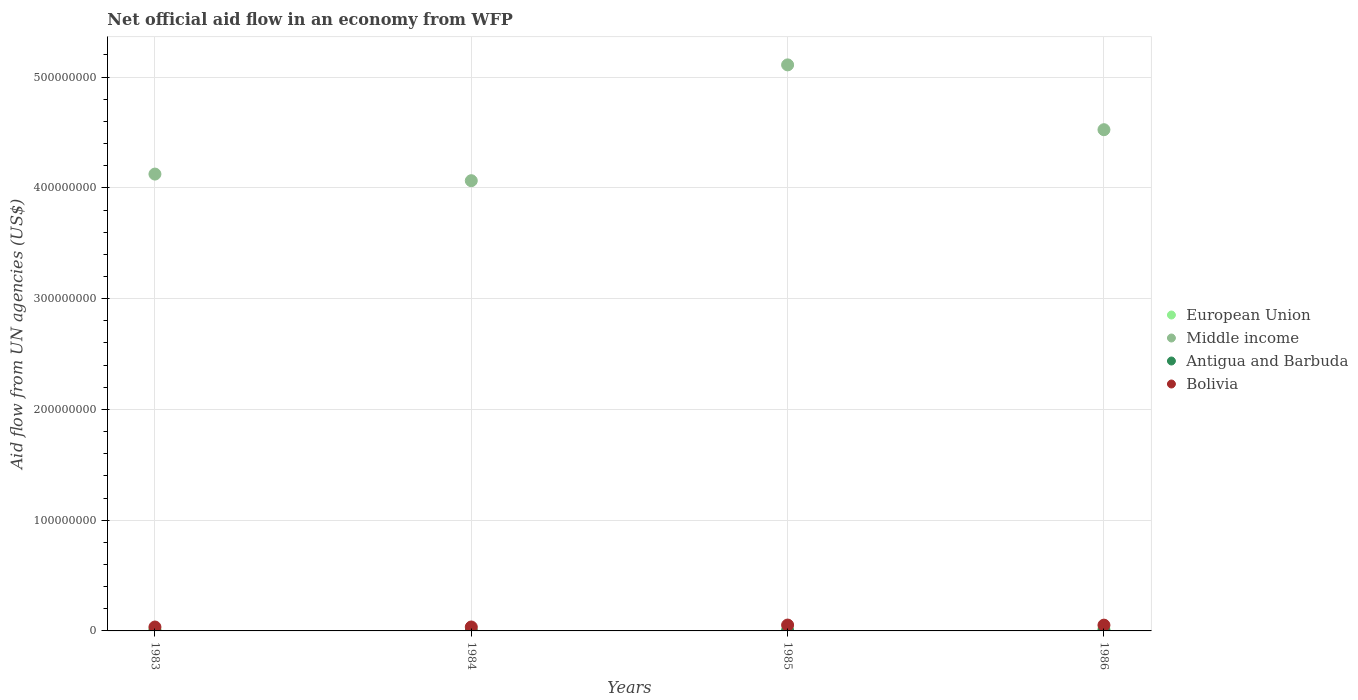How many different coloured dotlines are there?
Your response must be concise. 4. What is the net official aid flow in European Union in 1986?
Provide a short and direct response. 1.63e+06. Across all years, what is the maximum net official aid flow in Middle income?
Make the answer very short. 5.11e+08. Across all years, what is the minimum net official aid flow in Bolivia?
Your answer should be very brief. 3.52e+06. What is the total net official aid flow in Antigua and Barbuda in the graph?
Make the answer very short. 3.80e+05. What is the difference between the net official aid flow in Antigua and Barbuda in 1983 and that in 1984?
Give a very brief answer. 8.00e+04. What is the difference between the net official aid flow in Antigua and Barbuda in 1985 and the net official aid flow in Bolivia in 1983?
Provide a succinct answer. -3.39e+06. What is the average net official aid flow in Middle income per year?
Your answer should be very brief. 4.46e+08. In the year 1986, what is the difference between the net official aid flow in European Union and net official aid flow in Antigua and Barbuda?
Your answer should be very brief. 1.54e+06. In how many years, is the net official aid flow in European Union greater than 180000000 US$?
Make the answer very short. 0. What is the ratio of the net official aid flow in European Union in 1985 to that in 1986?
Offer a terse response. 0.45. What is the difference between the highest and the second highest net official aid flow in Middle income?
Your response must be concise. 5.85e+07. What is the difference between the highest and the lowest net official aid flow in Bolivia?
Give a very brief answer. 1.78e+06. In how many years, is the net official aid flow in Bolivia greater than the average net official aid flow in Bolivia taken over all years?
Your response must be concise. 2. Is the sum of the net official aid flow in Antigua and Barbuda in 1985 and 1986 greater than the maximum net official aid flow in European Union across all years?
Provide a short and direct response. No. Is it the case that in every year, the sum of the net official aid flow in Antigua and Barbuda and net official aid flow in Middle income  is greater than the sum of net official aid flow in Bolivia and net official aid flow in European Union?
Provide a short and direct response. Yes. Does the net official aid flow in European Union monotonically increase over the years?
Offer a very short reply. No. Is the net official aid flow in Middle income strictly greater than the net official aid flow in Bolivia over the years?
Offer a very short reply. Yes. How many dotlines are there?
Provide a succinct answer. 4. Are the values on the major ticks of Y-axis written in scientific E-notation?
Give a very brief answer. No. How many legend labels are there?
Offer a very short reply. 4. What is the title of the graph?
Provide a short and direct response. Net official aid flow in an economy from WFP. What is the label or title of the Y-axis?
Make the answer very short. Aid flow from UN agencies (US$). What is the Aid flow from UN agencies (US$) in European Union in 1983?
Keep it short and to the point. 1.25e+06. What is the Aid flow from UN agencies (US$) of Middle income in 1983?
Your answer should be compact. 4.12e+08. What is the Aid flow from UN agencies (US$) of Antigua and Barbuda in 1983?
Offer a very short reply. 1.20e+05. What is the Aid flow from UN agencies (US$) of Bolivia in 1983?
Your answer should be compact. 3.52e+06. What is the Aid flow from UN agencies (US$) in European Union in 1984?
Give a very brief answer. 2.20e+05. What is the Aid flow from UN agencies (US$) of Middle income in 1984?
Offer a very short reply. 4.06e+08. What is the Aid flow from UN agencies (US$) of Bolivia in 1984?
Offer a very short reply. 3.55e+06. What is the Aid flow from UN agencies (US$) in European Union in 1985?
Ensure brevity in your answer.  7.40e+05. What is the Aid flow from UN agencies (US$) of Middle income in 1985?
Your answer should be compact. 5.11e+08. What is the Aid flow from UN agencies (US$) in Bolivia in 1985?
Offer a very short reply. 5.30e+06. What is the Aid flow from UN agencies (US$) of European Union in 1986?
Your response must be concise. 1.63e+06. What is the Aid flow from UN agencies (US$) in Middle income in 1986?
Ensure brevity in your answer.  4.53e+08. What is the Aid flow from UN agencies (US$) of Bolivia in 1986?
Your response must be concise. 5.22e+06. Across all years, what is the maximum Aid flow from UN agencies (US$) in European Union?
Your response must be concise. 1.63e+06. Across all years, what is the maximum Aid flow from UN agencies (US$) of Middle income?
Your answer should be compact. 5.11e+08. Across all years, what is the maximum Aid flow from UN agencies (US$) in Antigua and Barbuda?
Your answer should be very brief. 1.30e+05. Across all years, what is the maximum Aid flow from UN agencies (US$) in Bolivia?
Make the answer very short. 5.30e+06. Across all years, what is the minimum Aid flow from UN agencies (US$) of Middle income?
Ensure brevity in your answer.  4.06e+08. Across all years, what is the minimum Aid flow from UN agencies (US$) of Antigua and Barbuda?
Offer a terse response. 4.00e+04. Across all years, what is the minimum Aid flow from UN agencies (US$) of Bolivia?
Your response must be concise. 3.52e+06. What is the total Aid flow from UN agencies (US$) in European Union in the graph?
Give a very brief answer. 3.84e+06. What is the total Aid flow from UN agencies (US$) of Middle income in the graph?
Provide a short and direct response. 1.78e+09. What is the total Aid flow from UN agencies (US$) in Antigua and Barbuda in the graph?
Offer a very short reply. 3.80e+05. What is the total Aid flow from UN agencies (US$) of Bolivia in the graph?
Your answer should be very brief. 1.76e+07. What is the difference between the Aid flow from UN agencies (US$) of European Union in 1983 and that in 1984?
Offer a very short reply. 1.03e+06. What is the difference between the Aid flow from UN agencies (US$) of Middle income in 1983 and that in 1984?
Your response must be concise. 5.98e+06. What is the difference between the Aid flow from UN agencies (US$) in European Union in 1983 and that in 1985?
Ensure brevity in your answer.  5.10e+05. What is the difference between the Aid flow from UN agencies (US$) in Middle income in 1983 and that in 1985?
Provide a succinct answer. -9.86e+07. What is the difference between the Aid flow from UN agencies (US$) in Antigua and Barbuda in 1983 and that in 1985?
Give a very brief answer. -10000. What is the difference between the Aid flow from UN agencies (US$) in Bolivia in 1983 and that in 1985?
Give a very brief answer. -1.78e+06. What is the difference between the Aid flow from UN agencies (US$) of European Union in 1983 and that in 1986?
Your answer should be compact. -3.80e+05. What is the difference between the Aid flow from UN agencies (US$) in Middle income in 1983 and that in 1986?
Your response must be concise. -4.01e+07. What is the difference between the Aid flow from UN agencies (US$) of Bolivia in 1983 and that in 1986?
Offer a very short reply. -1.70e+06. What is the difference between the Aid flow from UN agencies (US$) in European Union in 1984 and that in 1985?
Give a very brief answer. -5.20e+05. What is the difference between the Aid flow from UN agencies (US$) in Middle income in 1984 and that in 1985?
Your answer should be compact. -1.05e+08. What is the difference between the Aid flow from UN agencies (US$) of Bolivia in 1984 and that in 1985?
Your answer should be compact. -1.75e+06. What is the difference between the Aid flow from UN agencies (US$) in European Union in 1984 and that in 1986?
Give a very brief answer. -1.41e+06. What is the difference between the Aid flow from UN agencies (US$) of Middle income in 1984 and that in 1986?
Give a very brief answer. -4.60e+07. What is the difference between the Aid flow from UN agencies (US$) of Antigua and Barbuda in 1984 and that in 1986?
Provide a short and direct response. -5.00e+04. What is the difference between the Aid flow from UN agencies (US$) in Bolivia in 1984 and that in 1986?
Give a very brief answer. -1.67e+06. What is the difference between the Aid flow from UN agencies (US$) in European Union in 1985 and that in 1986?
Your answer should be compact. -8.90e+05. What is the difference between the Aid flow from UN agencies (US$) of Middle income in 1985 and that in 1986?
Your response must be concise. 5.85e+07. What is the difference between the Aid flow from UN agencies (US$) in Bolivia in 1985 and that in 1986?
Keep it short and to the point. 8.00e+04. What is the difference between the Aid flow from UN agencies (US$) of European Union in 1983 and the Aid flow from UN agencies (US$) of Middle income in 1984?
Your response must be concise. -4.05e+08. What is the difference between the Aid flow from UN agencies (US$) of European Union in 1983 and the Aid flow from UN agencies (US$) of Antigua and Barbuda in 1984?
Your answer should be compact. 1.21e+06. What is the difference between the Aid flow from UN agencies (US$) of European Union in 1983 and the Aid flow from UN agencies (US$) of Bolivia in 1984?
Keep it short and to the point. -2.30e+06. What is the difference between the Aid flow from UN agencies (US$) of Middle income in 1983 and the Aid flow from UN agencies (US$) of Antigua and Barbuda in 1984?
Your answer should be compact. 4.12e+08. What is the difference between the Aid flow from UN agencies (US$) of Middle income in 1983 and the Aid flow from UN agencies (US$) of Bolivia in 1984?
Offer a very short reply. 4.09e+08. What is the difference between the Aid flow from UN agencies (US$) in Antigua and Barbuda in 1983 and the Aid flow from UN agencies (US$) in Bolivia in 1984?
Make the answer very short. -3.43e+06. What is the difference between the Aid flow from UN agencies (US$) of European Union in 1983 and the Aid flow from UN agencies (US$) of Middle income in 1985?
Make the answer very short. -5.10e+08. What is the difference between the Aid flow from UN agencies (US$) of European Union in 1983 and the Aid flow from UN agencies (US$) of Antigua and Barbuda in 1985?
Provide a short and direct response. 1.12e+06. What is the difference between the Aid flow from UN agencies (US$) of European Union in 1983 and the Aid flow from UN agencies (US$) of Bolivia in 1985?
Your answer should be compact. -4.05e+06. What is the difference between the Aid flow from UN agencies (US$) of Middle income in 1983 and the Aid flow from UN agencies (US$) of Antigua and Barbuda in 1985?
Your answer should be compact. 4.12e+08. What is the difference between the Aid flow from UN agencies (US$) of Middle income in 1983 and the Aid flow from UN agencies (US$) of Bolivia in 1985?
Offer a terse response. 4.07e+08. What is the difference between the Aid flow from UN agencies (US$) of Antigua and Barbuda in 1983 and the Aid flow from UN agencies (US$) of Bolivia in 1985?
Provide a short and direct response. -5.18e+06. What is the difference between the Aid flow from UN agencies (US$) of European Union in 1983 and the Aid flow from UN agencies (US$) of Middle income in 1986?
Your answer should be very brief. -4.51e+08. What is the difference between the Aid flow from UN agencies (US$) in European Union in 1983 and the Aid flow from UN agencies (US$) in Antigua and Barbuda in 1986?
Your response must be concise. 1.16e+06. What is the difference between the Aid flow from UN agencies (US$) in European Union in 1983 and the Aid flow from UN agencies (US$) in Bolivia in 1986?
Your answer should be compact. -3.97e+06. What is the difference between the Aid flow from UN agencies (US$) in Middle income in 1983 and the Aid flow from UN agencies (US$) in Antigua and Barbuda in 1986?
Your answer should be very brief. 4.12e+08. What is the difference between the Aid flow from UN agencies (US$) of Middle income in 1983 and the Aid flow from UN agencies (US$) of Bolivia in 1986?
Your answer should be very brief. 4.07e+08. What is the difference between the Aid flow from UN agencies (US$) of Antigua and Barbuda in 1983 and the Aid flow from UN agencies (US$) of Bolivia in 1986?
Provide a succinct answer. -5.10e+06. What is the difference between the Aid flow from UN agencies (US$) in European Union in 1984 and the Aid flow from UN agencies (US$) in Middle income in 1985?
Give a very brief answer. -5.11e+08. What is the difference between the Aid flow from UN agencies (US$) in European Union in 1984 and the Aid flow from UN agencies (US$) in Antigua and Barbuda in 1985?
Keep it short and to the point. 9.00e+04. What is the difference between the Aid flow from UN agencies (US$) of European Union in 1984 and the Aid flow from UN agencies (US$) of Bolivia in 1985?
Make the answer very short. -5.08e+06. What is the difference between the Aid flow from UN agencies (US$) in Middle income in 1984 and the Aid flow from UN agencies (US$) in Antigua and Barbuda in 1985?
Your response must be concise. 4.06e+08. What is the difference between the Aid flow from UN agencies (US$) in Middle income in 1984 and the Aid flow from UN agencies (US$) in Bolivia in 1985?
Your answer should be compact. 4.01e+08. What is the difference between the Aid flow from UN agencies (US$) in Antigua and Barbuda in 1984 and the Aid flow from UN agencies (US$) in Bolivia in 1985?
Offer a very short reply. -5.26e+06. What is the difference between the Aid flow from UN agencies (US$) in European Union in 1984 and the Aid flow from UN agencies (US$) in Middle income in 1986?
Your answer should be compact. -4.52e+08. What is the difference between the Aid flow from UN agencies (US$) of European Union in 1984 and the Aid flow from UN agencies (US$) of Bolivia in 1986?
Provide a succinct answer. -5.00e+06. What is the difference between the Aid flow from UN agencies (US$) in Middle income in 1984 and the Aid flow from UN agencies (US$) in Antigua and Barbuda in 1986?
Ensure brevity in your answer.  4.06e+08. What is the difference between the Aid flow from UN agencies (US$) of Middle income in 1984 and the Aid flow from UN agencies (US$) of Bolivia in 1986?
Offer a very short reply. 4.01e+08. What is the difference between the Aid flow from UN agencies (US$) of Antigua and Barbuda in 1984 and the Aid flow from UN agencies (US$) of Bolivia in 1986?
Your response must be concise. -5.18e+06. What is the difference between the Aid flow from UN agencies (US$) of European Union in 1985 and the Aid flow from UN agencies (US$) of Middle income in 1986?
Your response must be concise. -4.52e+08. What is the difference between the Aid flow from UN agencies (US$) of European Union in 1985 and the Aid flow from UN agencies (US$) of Antigua and Barbuda in 1986?
Ensure brevity in your answer.  6.50e+05. What is the difference between the Aid flow from UN agencies (US$) in European Union in 1985 and the Aid flow from UN agencies (US$) in Bolivia in 1986?
Your answer should be compact. -4.48e+06. What is the difference between the Aid flow from UN agencies (US$) in Middle income in 1985 and the Aid flow from UN agencies (US$) in Antigua and Barbuda in 1986?
Make the answer very short. 5.11e+08. What is the difference between the Aid flow from UN agencies (US$) of Middle income in 1985 and the Aid flow from UN agencies (US$) of Bolivia in 1986?
Offer a terse response. 5.06e+08. What is the difference between the Aid flow from UN agencies (US$) in Antigua and Barbuda in 1985 and the Aid flow from UN agencies (US$) in Bolivia in 1986?
Offer a very short reply. -5.09e+06. What is the average Aid flow from UN agencies (US$) of European Union per year?
Offer a terse response. 9.60e+05. What is the average Aid flow from UN agencies (US$) in Middle income per year?
Make the answer very short. 4.46e+08. What is the average Aid flow from UN agencies (US$) of Antigua and Barbuda per year?
Your answer should be very brief. 9.50e+04. What is the average Aid flow from UN agencies (US$) in Bolivia per year?
Offer a terse response. 4.40e+06. In the year 1983, what is the difference between the Aid flow from UN agencies (US$) in European Union and Aid flow from UN agencies (US$) in Middle income?
Ensure brevity in your answer.  -4.11e+08. In the year 1983, what is the difference between the Aid flow from UN agencies (US$) of European Union and Aid flow from UN agencies (US$) of Antigua and Barbuda?
Offer a very short reply. 1.13e+06. In the year 1983, what is the difference between the Aid flow from UN agencies (US$) in European Union and Aid flow from UN agencies (US$) in Bolivia?
Keep it short and to the point. -2.27e+06. In the year 1983, what is the difference between the Aid flow from UN agencies (US$) of Middle income and Aid flow from UN agencies (US$) of Antigua and Barbuda?
Your answer should be compact. 4.12e+08. In the year 1983, what is the difference between the Aid flow from UN agencies (US$) in Middle income and Aid flow from UN agencies (US$) in Bolivia?
Offer a very short reply. 4.09e+08. In the year 1983, what is the difference between the Aid flow from UN agencies (US$) of Antigua and Barbuda and Aid flow from UN agencies (US$) of Bolivia?
Ensure brevity in your answer.  -3.40e+06. In the year 1984, what is the difference between the Aid flow from UN agencies (US$) of European Union and Aid flow from UN agencies (US$) of Middle income?
Make the answer very short. -4.06e+08. In the year 1984, what is the difference between the Aid flow from UN agencies (US$) of European Union and Aid flow from UN agencies (US$) of Bolivia?
Your answer should be very brief. -3.33e+06. In the year 1984, what is the difference between the Aid flow from UN agencies (US$) in Middle income and Aid flow from UN agencies (US$) in Antigua and Barbuda?
Provide a succinct answer. 4.06e+08. In the year 1984, what is the difference between the Aid flow from UN agencies (US$) in Middle income and Aid flow from UN agencies (US$) in Bolivia?
Ensure brevity in your answer.  4.03e+08. In the year 1984, what is the difference between the Aid flow from UN agencies (US$) in Antigua and Barbuda and Aid flow from UN agencies (US$) in Bolivia?
Your response must be concise. -3.51e+06. In the year 1985, what is the difference between the Aid flow from UN agencies (US$) in European Union and Aid flow from UN agencies (US$) in Middle income?
Offer a terse response. -5.10e+08. In the year 1985, what is the difference between the Aid flow from UN agencies (US$) in European Union and Aid flow from UN agencies (US$) in Bolivia?
Ensure brevity in your answer.  -4.56e+06. In the year 1985, what is the difference between the Aid flow from UN agencies (US$) of Middle income and Aid flow from UN agencies (US$) of Antigua and Barbuda?
Make the answer very short. 5.11e+08. In the year 1985, what is the difference between the Aid flow from UN agencies (US$) in Middle income and Aid flow from UN agencies (US$) in Bolivia?
Provide a short and direct response. 5.06e+08. In the year 1985, what is the difference between the Aid flow from UN agencies (US$) in Antigua and Barbuda and Aid flow from UN agencies (US$) in Bolivia?
Your response must be concise. -5.17e+06. In the year 1986, what is the difference between the Aid flow from UN agencies (US$) in European Union and Aid flow from UN agencies (US$) in Middle income?
Your response must be concise. -4.51e+08. In the year 1986, what is the difference between the Aid flow from UN agencies (US$) in European Union and Aid flow from UN agencies (US$) in Antigua and Barbuda?
Keep it short and to the point. 1.54e+06. In the year 1986, what is the difference between the Aid flow from UN agencies (US$) in European Union and Aid flow from UN agencies (US$) in Bolivia?
Provide a succinct answer. -3.59e+06. In the year 1986, what is the difference between the Aid flow from UN agencies (US$) in Middle income and Aid flow from UN agencies (US$) in Antigua and Barbuda?
Provide a short and direct response. 4.52e+08. In the year 1986, what is the difference between the Aid flow from UN agencies (US$) of Middle income and Aid flow from UN agencies (US$) of Bolivia?
Provide a succinct answer. 4.47e+08. In the year 1986, what is the difference between the Aid flow from UN agencies (US$) of Antigua and Barbuda and Aid flow from UN agencies (US$) of Bolivia?
Your answer should be compact. -5.13e+06. What is the ratio of the Aid flow from UN agencies (US$) of European Union in 1983 to that in 1984?
Your response must be concise. 5.68. What is the ratio of the Aid flow from UN agencies (US$) of Middle income in 1983 to that in 1984?
Provide a short and direct response. 1.01. What is the ratio of the Aid flow from UN agencies (US$) in Antigua and Barbuda in 1983 to that in 1984?
Give a very brief answer. 3. What is the ratio of the Aid flow from UN agencies (US$) in European Union in 1983 to that in 1985?
Keep it short and to the point. 1.69. What is the ratio of the Aid flow from UN agencies (US$) of Middle income in 1983 to that in 1985?
Offer a very short reply. 0.81. What is the ratio of the Aid flow from UN agencies (US$) of Bolivia in 1983 to that in 1985?
Your answer should be compact. 0.66. What is the ratio of the Aid flow from UN agencies (US$) in European Union in 1983 to that in 1986?
Your response must be concise. 0.77. What is the ratio of the Aid flow from UN agencies (US$) of Middle income in 1983 to that in 1986?
Your response must be concise. 0.91. What is the ratio of the Aid flow from UN agencies (US$) of Antigua and Barbuda in 1983 to that in 1986?
Your answer should be compact. 1.33. What is the ratio of the Aid flow from UN agencies (US$) of Bolivia in 1983 to that in 1986?
Provide a short and direct response. 0.67. What is the ratio of the Aid flow from UN agencies (US$) in European Union in 1984 to that in 1985?
Your response must be concise. 0.3. What is the ratio of the Aid flow from UN agencies (US$) of Middle income in 1984 to that in 1985?
Offer a very short reply. 0.8. What is the ratio of the Aid flow from UN agencies (US$) in Antigua and Barbuda in 1984 to that in 1985?
Give a very brief answer. 0.31. What is the ratio of the Aid flow from UN agencies (US$) in Bolivia in 1984 to that in 1985?
Keep it short and to the point. 0.67. What is the ratio of the Aid flow from UN agencies (US$) of European Union in 1984 to that in 1986?
Your response must be concise. 0.14. What is the ratio of the Aid flow from UN agencies (US$) of Middle income in 1984 to that in 1986?
Your answer should be compact. 0.9. What is the ratio of the Aid flow from UN agencies (US$) in Antigua and Barbuda in 1984 to that in 1986?
Provide a succinct answer. 0.44. What is the ratio of the Aid flow from UN agencies (US$) of Bolivia in 1984 to that in 1986?
Keep it short and to the point. 0.68. What is the ratio of the Aid flow from UN agencies (US$) of European Union in 1985 to that in 1986?
Ensure brevity in your answer.  0.45. What is the ratio of the Aid flow from UN agencies (US$) of Middle income in 1985 to that in 1986?
Your response must be concise. 1.13. What is the ratio of the Aid flow from UN agencies (US$) of Antigua and Barbuda in 1985 to that in 1986?
Offer a very short reply. 1.44. What is the ratio of the Aid flow from UN agencies (US$) in Bolivia in 1985 to that in 1986?
Keep it short and to the point. 1.02. What is the difference between the highest and the second highest Aid flow from UN agencies (US$) in European Union?
Your response must be concise. 3.80e+05. What is the difference between the highest and the second highest Aid flow from UN agencies (US$) of Middle income?
Make the answer very short. 5.85e+07. What is the difference between the highest and the second highest Aid flow from UN agencies (US$) of Bolivia?
Give a very brief answer. 8.00e+04. What is the difference between the highest and the lowest Aid flow from UN agencies (US$) in European Union?
Provide a succinct answer. 1.41e+06. What is the difference between the highest and the lowest Aid flow from UN agencies (US$) of Middle income?
Ensure brevity in your answer.  1.05e+08. What is the difference between the highest and the lowest Aid flow from UN agencies (US$) in Bolivia?
Your response must be concise. 1.78e+06. 